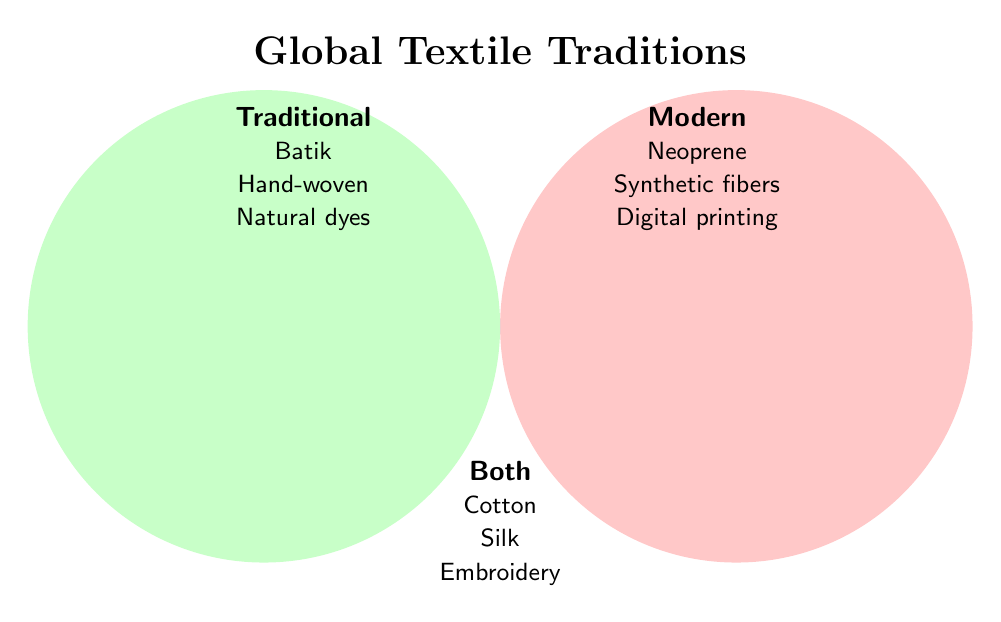What is the title of the Venn Diagram? The title is located at the top of the figure, written in bold and large font.
Answer: Global Textile Traditions What textile techniques are shared between both traditional and modern categories? Look in the overlapping area of the Venn Diagram where the two circles intersect, labeled "Both".
Answer: Cotton, Silk, Embroidery, Beadwork, Lace, Velvet, Leather Which category does Batik belong to? Batik is listed in the "Traditional" section of the Venn Diagram.
Answer: Traditional Name one modern textile technique mentioned in the diagram. Look in the "Modern" section of the Venn Diagram for a list of techniques.
Answer: Neoprene (alternatively, Synthetic fibers, Digital printing, Laser-cut fabrics, Smart textiles, Recycled materials, 3D-printed fabrics) How many textile techniques are labeled as modern? Count the number of items listed under the "Modern" section.
Answer: Seven Which textile techniques involve dyeing methods? Identify techniques related to dyeing in the traditional and both categories.
Answer: Indigo dyeing (Traditional), Natural dyes (Traditional), and none in modern Do traditional techniques outnumber modern techniques? Count the number of items in each section and compare them: Traditional (8), Modern (7).
Answer: No Are there any textile techniques related to patterns? Yes, identify techniques related to patterns in traditional and both categories.
Answer: Tribal patterns (Traditional), Ikat (Traditional), Embroidery (Both) What is the total number of unique textile techniques mentioned in the diagram? Count the techniques listed in the traditional, modern, and both sections individually, considering the overlapping techniques only once. There are 8 (Traditional) + 7 (Modern) - 7 (Both overlap) + 7 (Both unique) = 15.
Answer: Fifteen Which textile technique categories include Leather? Look for Leather in the sections of the Venn Diagram: It is listed in the "Both" section.
Answer: Both 